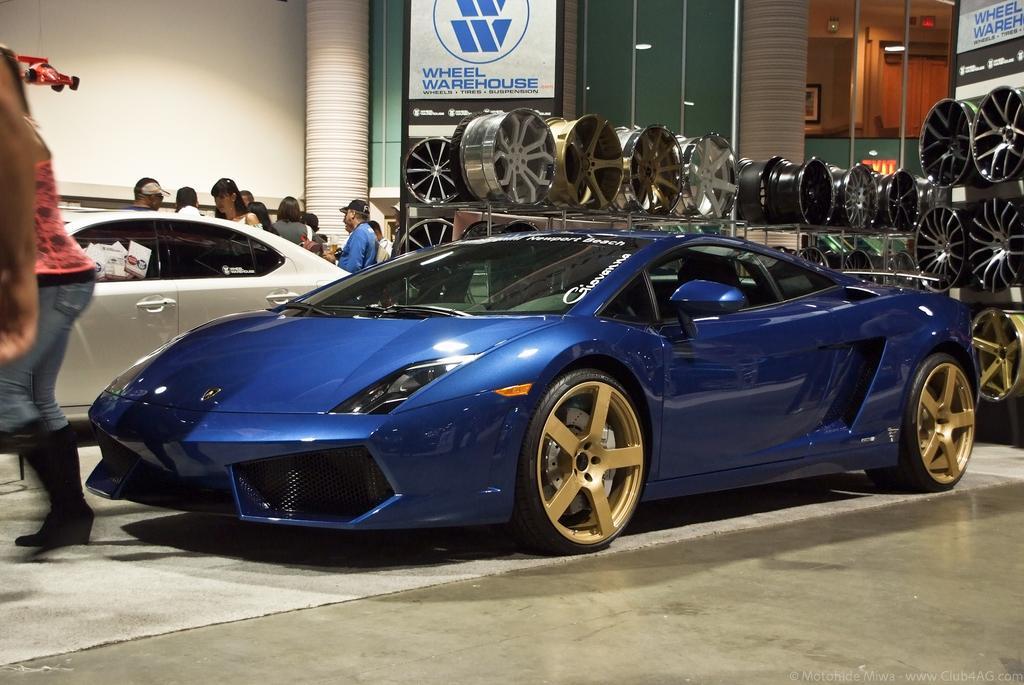Please provide a concise description of this image. In this image we can see there are two cars, beside the cars there are a few people standing. On the right side of the image there are few objects placed in a rack. In the background there is a wall. 